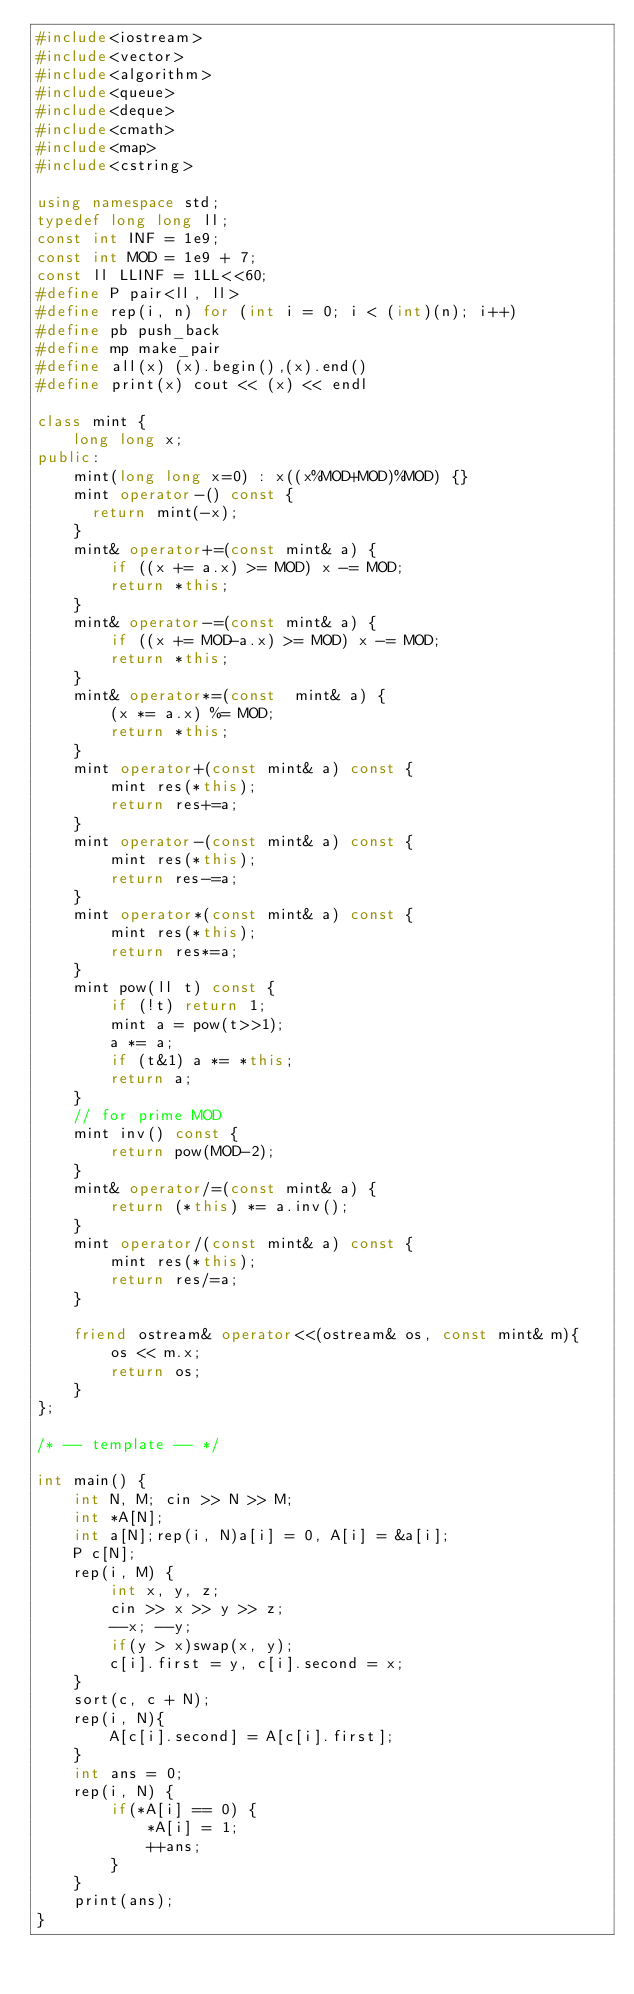Convert code to text. <code><loc_0><loc_0><loc_500><loc_500><_C++_>#include<iostream>
#include<vector>
#include<algorithm>
#include<queue>
#include<deque>
#include<cmath>
#include<map>
#include<cstring>

using namespace std;
typedef long long ll;
const int INF = 1e9;
const int MOD = 1e9 + 7;
const ll LLINF = 1LL<<60;
#define P pair<ll, ll>
#define rep(i, n) for (int i = 0; i < (int)(n); i++)
#define pb push_back
#define mp make_pair
#define all(x) (x).begin(),(x).end()
#define print(x) cout << (x) << endl

class mint {
    long long x;
public:
    mint(long long x=0) : x((x%MOD+MOD)%MOD) {}
    mint operator-() const {
      return mint(-x);
    }
    mint& operator+=(const mint& a) {
        if ((x += a.x) >= MOD) x -= MOD;
        return *this;
    }
    mint& operator-=(const mint& a) {
        if ((x += MOD-a.x) >= MOD) x -= MOD;
        return *this;
    }
    mint& operator*=(const  mint& a) {
        (x *= a.x) %= MOD;
        return *this;
    }
    mint operator+(const mint& a) const {
        mint res(*this);
        return res+=a;
    }
    mint operator-(const mint& a) const {
        mint res(*this);
        return res-=a;
    }
    mint operator*(const mint& a) const {
        mint res(*this);
        return res*=a;
    }
    mint pow(ll t) const {
        if (!t) return 1;
        mint a = pow(t>>1);
        a *= a;
        if (t&1) a *= *this;
        return a;
    }
    // for prime MOD
    mint inv() const {
        return pow(MOD-2);
    }
    mint& operator/=(const mint& a) {
        return (*this) *= a.inv();
    }
    mint operator/(const mint& a) const {
        mint res(*this);
        return res/=a;
    }

    friend ostream& operator<<(ostream& os, const mint& m){
        os << m.x;
        return os;
    }
};

/* -- template -- */

int main() {
    int N, M; cin >> N >> M;
    int *A[N];
    int a[N];rep(i, N)a[i] = 0, A[i] = &a[i];
    P c[N];
    rep(i, M) {
        int x, y, z;
        cin >> x >> y >> z;
        --x; --y;
        if(y > x)swap(x, y);
        c[i].first = y, c[i].second = x;
    }
    sort(c, c + N);
    rep(i, N){
        A[c[i].second] = A[c[i].first];
    }
    int ans = 0;
    rep(i, N) {
        if(*A[i] == 0) {
            *A[i] = 1;
            ++ans;
        }
    }
    print(ans);
}
</code> 